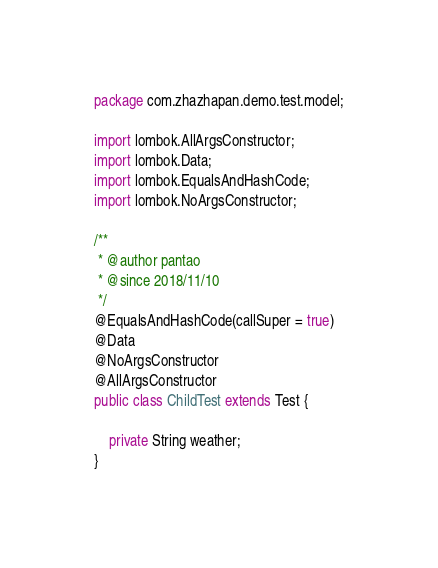<code> <loc_0><loc_0><loc_500><loc_500><_Java_>package com.zhazhapan.demo.test.model;

import lombok.AllArgsConstructor;
import lombok.Data;
import lombok.EqualsAndHashCode;
import lombok.NoArgsConstructor;

/**
 * @author pantao
 * @since 2018/11/10
 */
@EqualsAndHashCode(callSuper = true)
@Data
@NoArgsConstructor
@AllArgsConstructor
public class ChildTest extends Test {

    private String weather;
}
</code> 